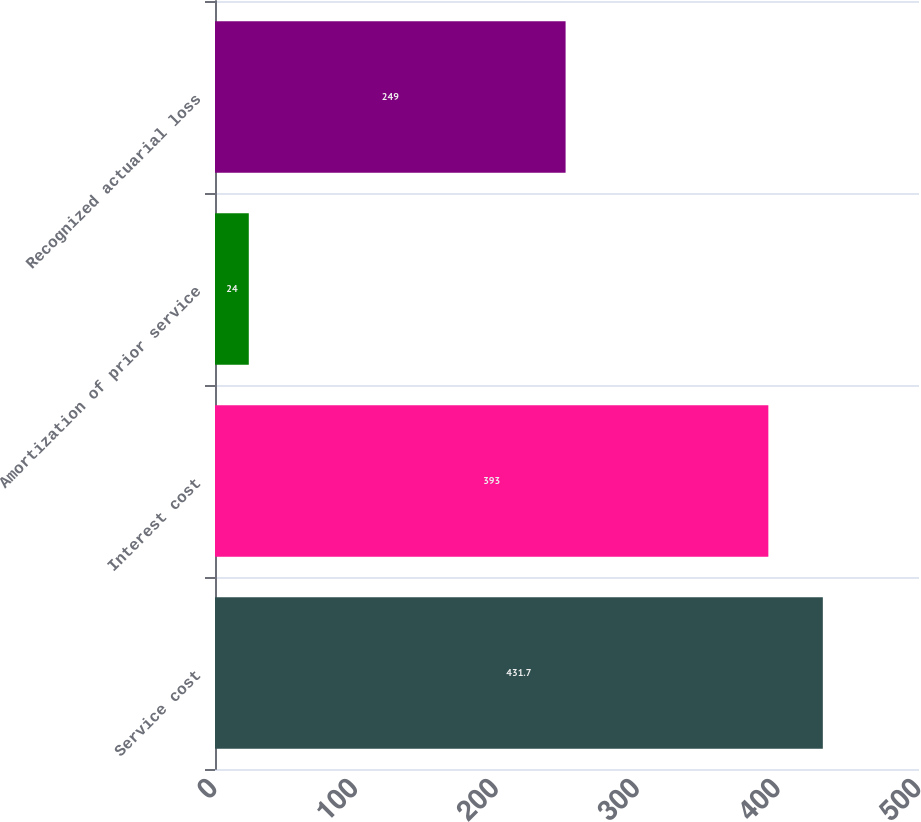Convert chart to OTSL. <chart><loc_0><loc_0><loc_500><loc_500><bar_chart><fcel>Service cost<fcel>Interest cost<fcel>Amortization of prior service<fcel>Recognized actuarial loss<nl><fcel>431.7<fcel>393<fcel>24<fcel>249<nl></chart> 